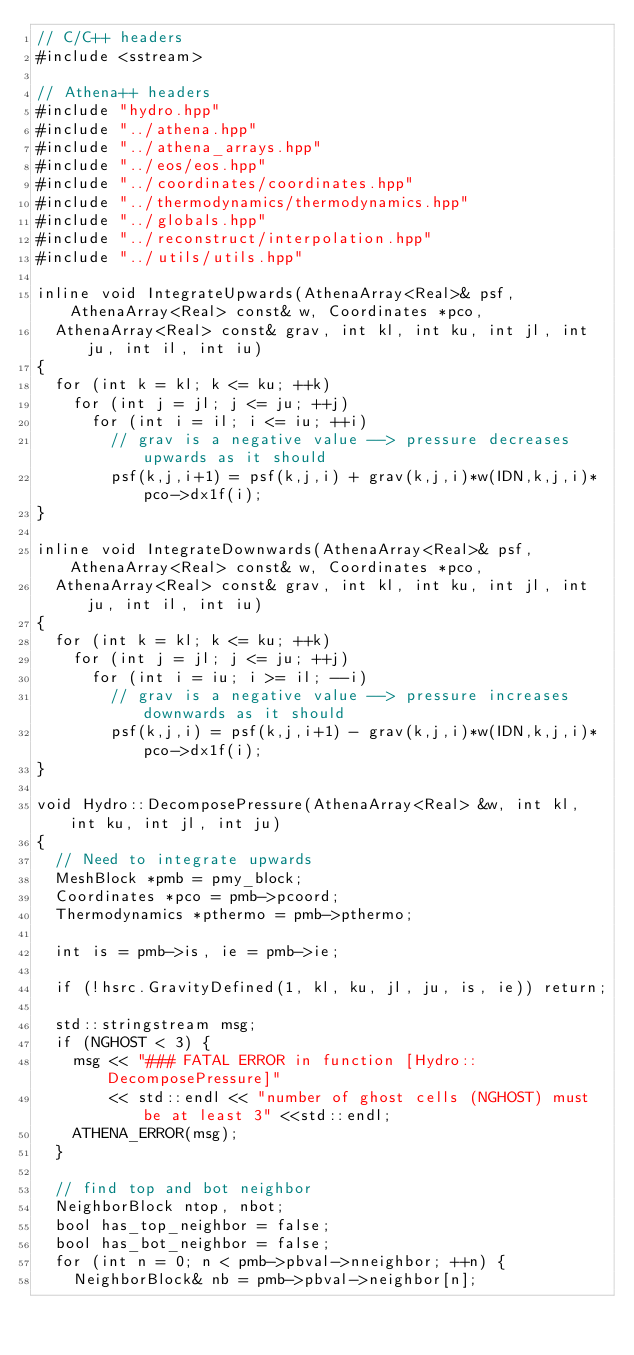<code> <loc_0><loc_0><loc_500><loc_500><_C++_>// C/C++ headers
#include <sstream>

// Athena++ headers
#include "hydro.hpp"
#include "../athena.hpp"
#include "../athena_arrays.hpp"
#include "../eos/eos.hpp"
#include "../coordinates/coordinates.hpp"
#include "../thermodynamics/thermodynamics.hpp"
#include "../globals.hpp"
#include "../reconstruct/interpolation.hpp"
#include "../utils/utils.hpp"

inline void IntegrateUpwards(AthenaArray<Real>& psf, AthenaArray<Real> const& w, Coordinates *pco,
  AthenaArray<Real> const& grav, int kl, int ku, int jl, int ju, int il, int iu)
{
  for (int k = kl; k <= ku; ++k)
    for (int j = jl; j <= ju; ++j)
      for (int i = il; i <= iu; ++i)
        // grav is a negative value --> pressure decreases upwards as it should
        psf(k,j,i+1) = psf(k,j,i) + grav(k,j,i)*w(IDN,k,j,i)*pco->dx1f(i);
}

inline void IntegrateDownwards(AthenaArray<Real>& psf, AthenaArray<Real> const& w, Coordinates *pco,
  AthenaArray<Real> const& grav, int kl, int ku, int jl, int ju, int il, int iu)
{
  for (int k = kl; k <= ku; ++k)
    for (int j = jl; j <= ju; ++j)
      for (int i = iu; i >= il; --i)
        // grav is a negative value --> pressure increases downwards as it should
        psf(k,j,i) = psf(k,j,i+1) - grav(k,j,i)*w(IDN,k,j,i)*pco->dx1f(i);
}

void Hydro::DecomposePressure(AthenaArray<Real> &w, int kl, int ku, int jl, int ju)
{
  // Need to integrate upwards
  MeshBlock *pmb = pmy_block;
  Coordinates *pco = pmb->pcoord;
  Thermodynamics *pthermo = pmb->pthermo;

  int is = pmb->is, ie = pmb->ie;
  
  if (!hsrc.GravityDefined(1, kl, ku, jl, ju, is, ie)) return;

  std::stringstream msg;
  if (NGHOST < 3) {
    msg << "### FATAL ERROR in function [Hydro::DecomposePressure]"
        << std::endl << "number of ghost cells (NGHOST) must be at least 3" <<std::endl;
    ATHENA_ERROR(msg);
  }

  // find top and bot neighbor
  NeighborBlock ntop, nbot;
  bool has_top_neighbor = false;
  bool has_bot_neighbor = false;
  for (int n = 0; n < pmb->pbval->nneighbor; ++n) {
    NeighborBlock& nb = pmb->pbval->neighbor[n];</code> 